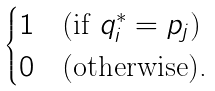<formula> <loc_0><loc_0><loc_500><loc_500>\begin{cases} 1 & \text {(if $q_{i}^{*}=p_{j}$)} \\ 0 & \text {(otherwise).} \end{cases}</formula> 